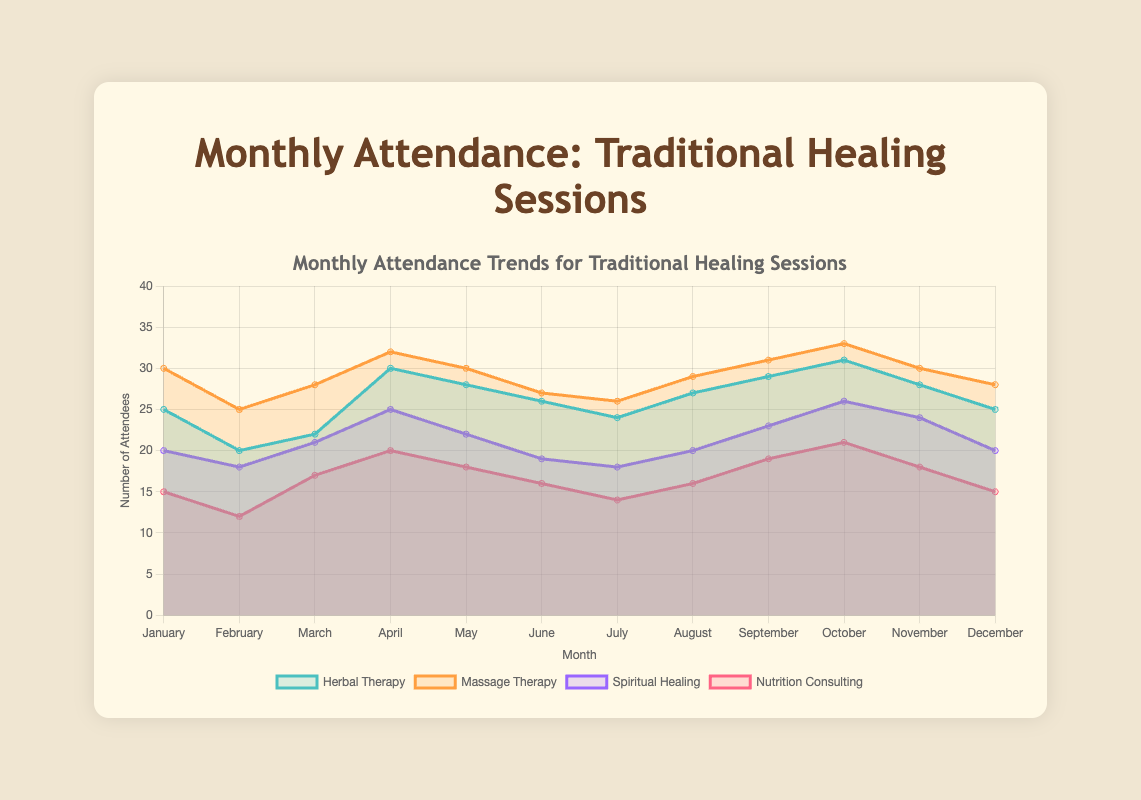What is the title of the chart? The title of the chart is displayed at the top and reads 'Monthly Attendance Trends for Traditional Healing Sessions'.
Answer: 'Monthly Attendance Trends for Traditional Healing Sessions' What is the highest number of attendees recorded for any session? By looking at the y-axis and identifying the highest data point on the chart, we see that the 'Massage Therapy' session in October has the highest number of attendees, which is 33.
Answer: 33 How does the attendance of 'Spiritual Healing' in May compare to that in July? Comparing the points for 'Spiritual Healing' in May and July, we see that in May it had 22 attendees and in July it had 18 attendees. Therefore, the attendance in May is 4 attendees higher than in July.
Answer: 4 attendees higher What is the average number of attendees for 'Nutrition Consulting' in the first quarter (January, February, March)? To find the average, sum the attendees for 'Nutrition Consulting' in January (15), February (12), and March (17), and then divide by 3. The sum is 44, so the average is 44/3 ≈ 14.67.
Answer: 14.67 Which type of healing session had the most consistent attendance throughout the year? By examining the fluctuations in attendance for each type of session over the months, 'Herbal Therapy' and 'Massage Therapy' show slight variations, but 'Spiritual Healing' and 'Nutrition Consulting' have more fluctuations. 'Massage Therapy' appears to be the most consistent.
Answer: 'Massage Therapy' What was the total attendance for 'Herbal Therapy' over the whole year? Adding up the monthly attendees for 'Herbal Therapy' (25 + 20 + 22 + 30 + 28 + 26 + 24 + 27 + 29 + 31 + 28 + 25) gives a total of 315.
Answer: 315 In which month did 'Nutrition Consulting' have the lowest attendance, and what was the number? Identifying the lowest point in the chart for 'Nutrition Consulting', February had the lowest attendance with 12 attendees.
Answer: February, 12 Which session saw the largest drop in attendees between consecutive months, and by how many attendees? Looking at the changes from month to month, 'Herbal Therapy' shows the largest drop between January (25) and February (20), with a drop of 5 attendees.
Answer: 'Herbal Therapy', 5 attendees How did the number of attendees for all sessions trend from January to December? Observing the overall trend, most sessions (such as 'Herbal Therapy', 'Massage Therapy', and 'Spiritual Healing') show a general increase from January to December, peaking in October and decreasing slightly in November and December.
Answer: Gradual increase, peak in October, slight decrease toward year-end 